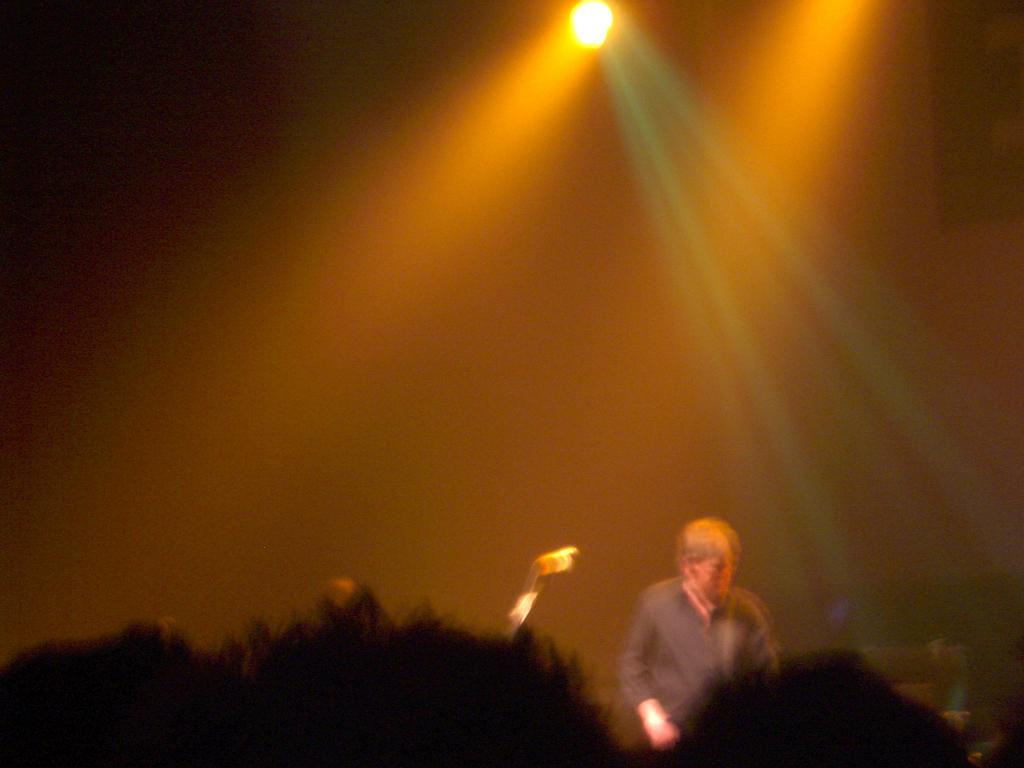What is the main subject of the image? There is a man standing in the image. What object is located behind the man? There is a microphone behind the man. What can be seen at the top of the image? There is a light at the top of the image. How many wrens can be seen perched on the plate in the image? There are no wrens or plates present in the image. What type of pull can be observed in the image? There is no pull or any action that can be observed in the image. 